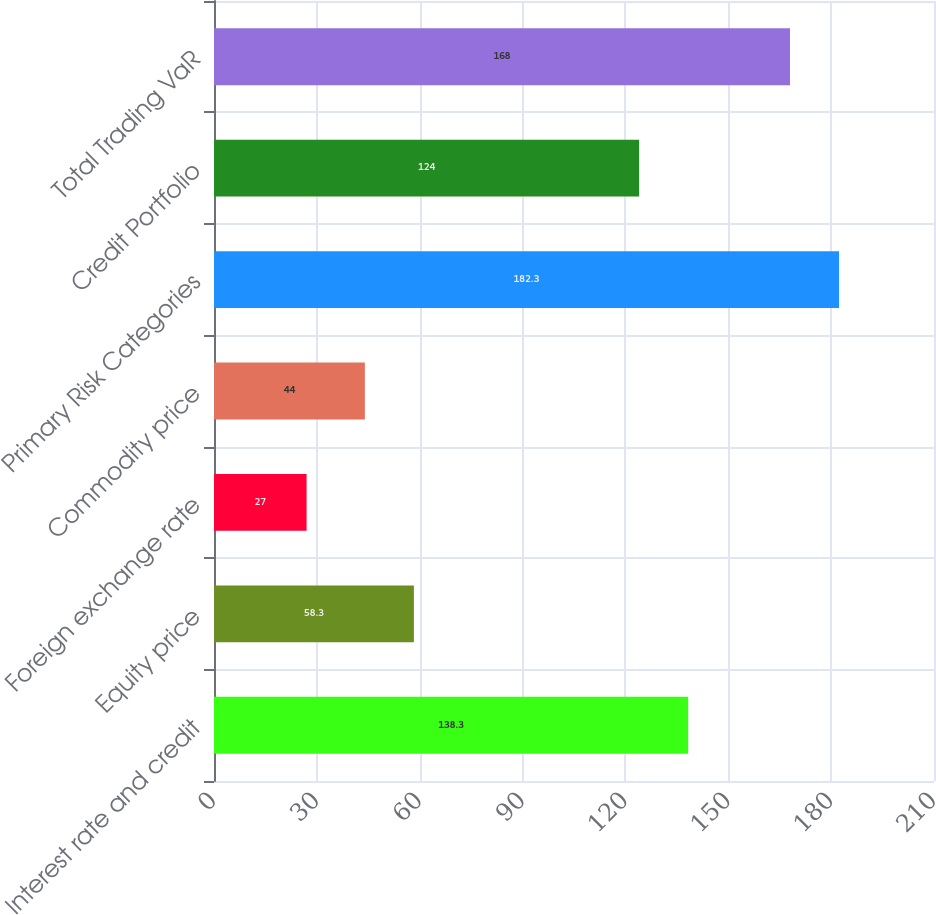<chart> <loc_0><loc_0><loc_500><loc_500><bar_chart><fcel>Interest rate and credit<fcel>Equity price<fcel>Foreign exchange rate<fcel>Commodity price<fcel>Primary Risk Categories<fcel>Credit Portfolio<fcel>Total Trading VaR<nl><fcel>138.3<fcel>58.3<fcel>27<fcel>44<fcel>182.3<fcel>124<fcel>168<nl></chart> 